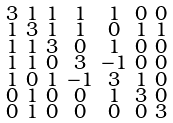Convert formula to latex. <formula><loc_0><loc_0><loc_500><loc_500>\begin{smallmatrix} 3 & 1 & 1 & 1 & 1 & 0 & 0 \\ 1 & 3 & 1 & 1 & 0 & 1 & 1 \\ 1 & 1 & 3 & 0 & 1 & 0 & 0 \\ 1 & 1 & 0 & 3 & - 1 & 0 & 0 \\ 1 & 0 & 1 & - 1 & 3 & 1 & 0 \\ 0 & 1 & 0 & 0 & 1 & 3 & 0 \\ 0 & 1 & 0 & 0 & 0 & 0 & 3 \end{smallmatrix}</formula> 